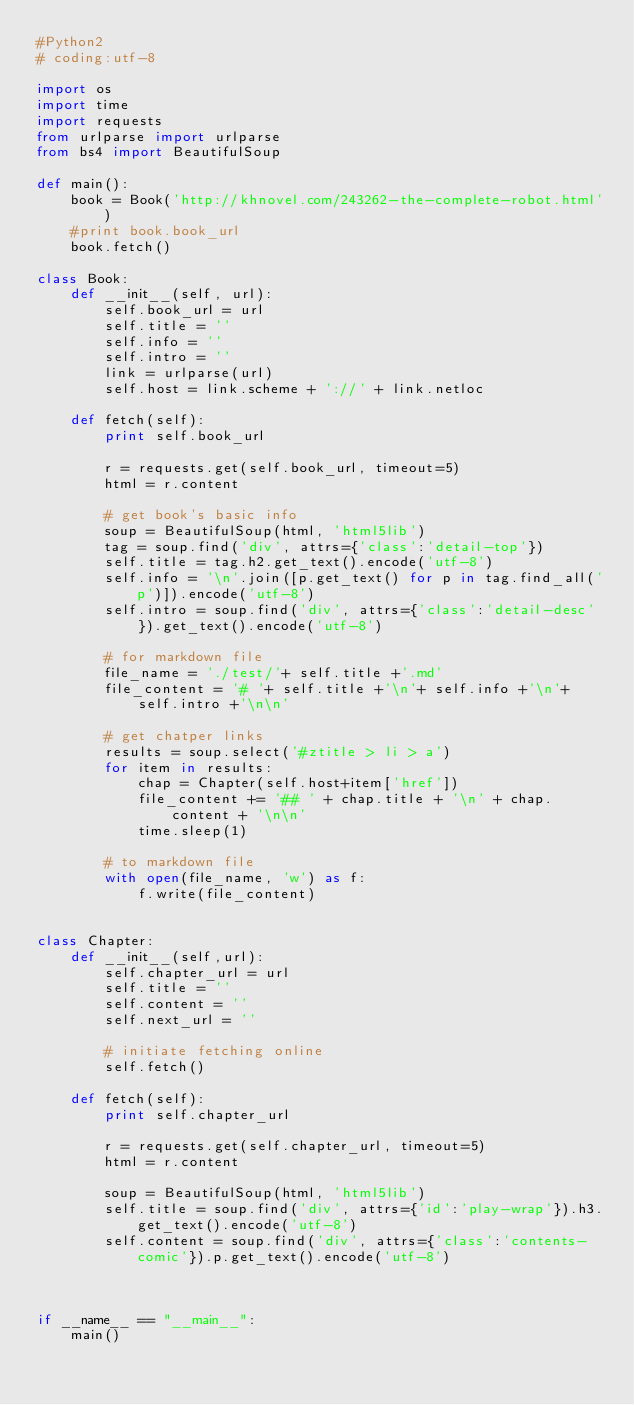Convert code to text. <code><loc_0><loc_0><loc_500><loc_500><_Python_>#Python2
# coding:utf-8

import os
import time
import requests
from urlparse import urlparse
from bs4 import BeautifulSoup

def main():
    book = Book('http://khnovel.com/243262-the-complete-robot.html')
    #print book.book_url
    book.fetch()

class Book:
    def __init__(self, url):
        self.book_url = url
        self.title = ''
        self.info = ''
        self.intro = ''
        link = urlparse(url)
        self.host = link.scheme + '://' + link.netloc

    def fetch(self):
        print self.book_url

        r = requests.get(self.book_url, timeout=5)
        html = r.content

        # get book's basic info
        soup = BeautifulSoup(html, 'html5lib')
        tag = soup.find('div', attrs={'class':'detail-top'})
        self.title = tag.h2.get_text().encode('utf-8')
        self.info = '\n'.join([p.get_text() for p in tag.find_all('p')]).encode('utf-8')
        self.intro = soup.find('div', attrs={'class':'detail-desc'}).get_text().encode('utf-8')

        # for markdown file
        file_name = './test/'+ self.title +'.md'
        file_content = '# '+ self.title +'\n'+ self.info +'\n'+ self.intro +'\n\n'

        # get chatper links
        results = soup.select('#ztitle > li > a')
        for item in results:
            chap = Chapter(self.host+item['href'])
            file_content += '## ' + chap.title + '\n' + chap.content + '\n\n'
            time.sleep(1)

        # to markdown file
        with open(file_name, 'w') as f:
            f.write(file_content)


class Chapter:
    def __init__(self,url):
        self.chapter_url = url
        self.title = ''
        self.content = ''
        self.next_url = ''
        
        # initiate fetching online
        self.fetch()

    def fetch(self):
        print self.chapter_url
        
        r = requests.get(self.chapter_url, timeout=5)
        html = r.content

        soup = BeautifulSoup(html, 'html5lib')
        self.title = soup.find('div', attrs={'id':'play-wrap'}).h3.get_text().encode('utf-8')
        self.content = soup.find('div', attrs={'class':'contents-comic'}).p.get_text().encode('utf-8')



if __name__ == "__main__":
    main()
</code> 